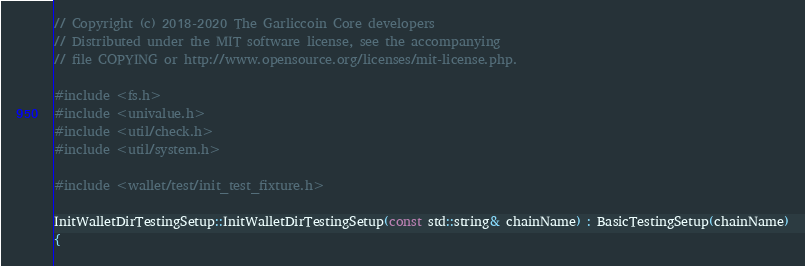Convert code to text. <code><loc_0><loc_0><loc_500><loc_500><_C++_>// Copyright (c) 2018-2020 The Garliccoin Core developers
// Distributed under the MIT software license, see the accompanying
// file COPYING or http://www.opensource.org/licenses/mit-license.php.

#include <fs.h>
#include <univalue.h>
#include <util/check.h>
#include <util/system.h>

#include <wallet/test/init_test_fixture.h>

InitWalletDirTestingSetup::InitWalletDirTestingSetup(const std::string& chainName) : BasicTestingSetup(chainName)
{</code> 